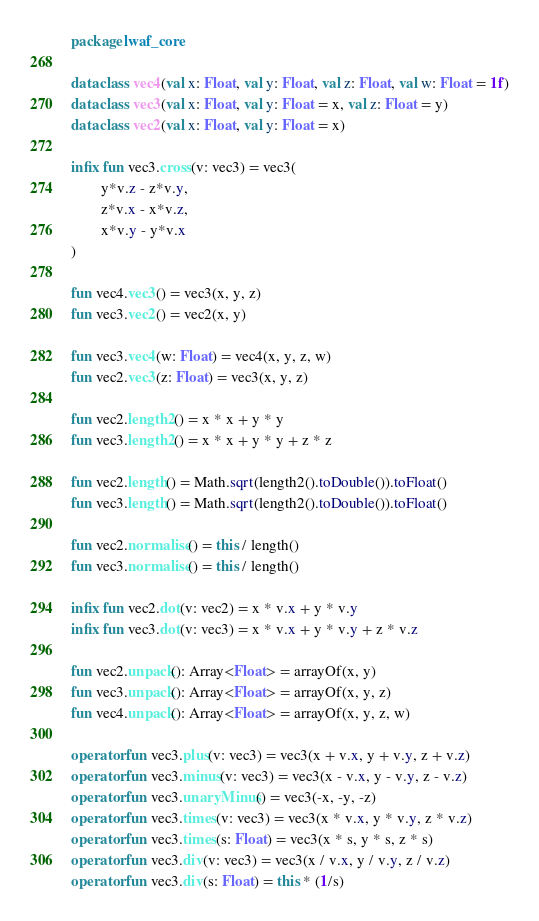<code> <loc_0><loc_0><loc_500><loc_500><_Kotlin_>package lwaf_core

data class vec4(val x: Float, val y: Float, val z: Float, val w: Float = 1f)
data class vec3(val x: Float, val y: Float = x, val z: Float = y)
data class vec2(val x: Float, val y: Float = x)

infix fun vec3.cross(v: vec3) = vec3(
        y*v.z - z*v.y,
        z*v.x - x*v.z,
        x*v.y - y*v.x
)

fun vec4.vec3() = vec3(x, y, z)
fun vec3.vec2() = vec2(x, y)

fun vec3.vec4(w: Float) = vec4(x, y, z, w)
fun vec2.vec3(z: Float) = vec3(x, y, z)

fun vec2.length2() = x * x + y * y
fun vec3.length2() = x * x + y * y + z * z

fun vec2.length() = Math.sqrt(length2().toDouble()).toFloat()
fun vec3.length() = Math.sqrt(length2().toDouble()).toFloat()

fun vec2.normalise() = this / length()
fun vec3.normalise() = this / length()

infix fun vec2.dot(v: vec2) = x * v.x + y * v.y
infix fun vec3.dot(v: vec3) = x * v.x + y * v.y + z * v.z

fun vec2.unpack(): Array<Float> = arrayOf(x, y)
fun vec3.unpack(): Array<Float> = arrayOf(x, y, z)
fun vec4.unpack(): Array<Float> = arrayOf(x, y, z, w)

operator fun vec3.plus(v: vec3) = vec3(x + v.x, y + v.y, z + v.z)
operator fun vec3.minus(v: vec3) = vec3(x - v.x, y - v.y, z - v.z)
operator fun vec3.unaryMinus() = vec3(-x, -y, -z)
operator fun vec3.times(v: vec3) = vec3(x * v.x, y * v.y, z * v.z)
operator fun vec3.times(s: Float) = vec3(x * s, y * s, z * s)
operator fun vec3.div(v: vec3) = vec3(x / v.x, y / v.y, z / v.z)
operator fun vec3.div(s: Float) = this * (1/s)
</code> 